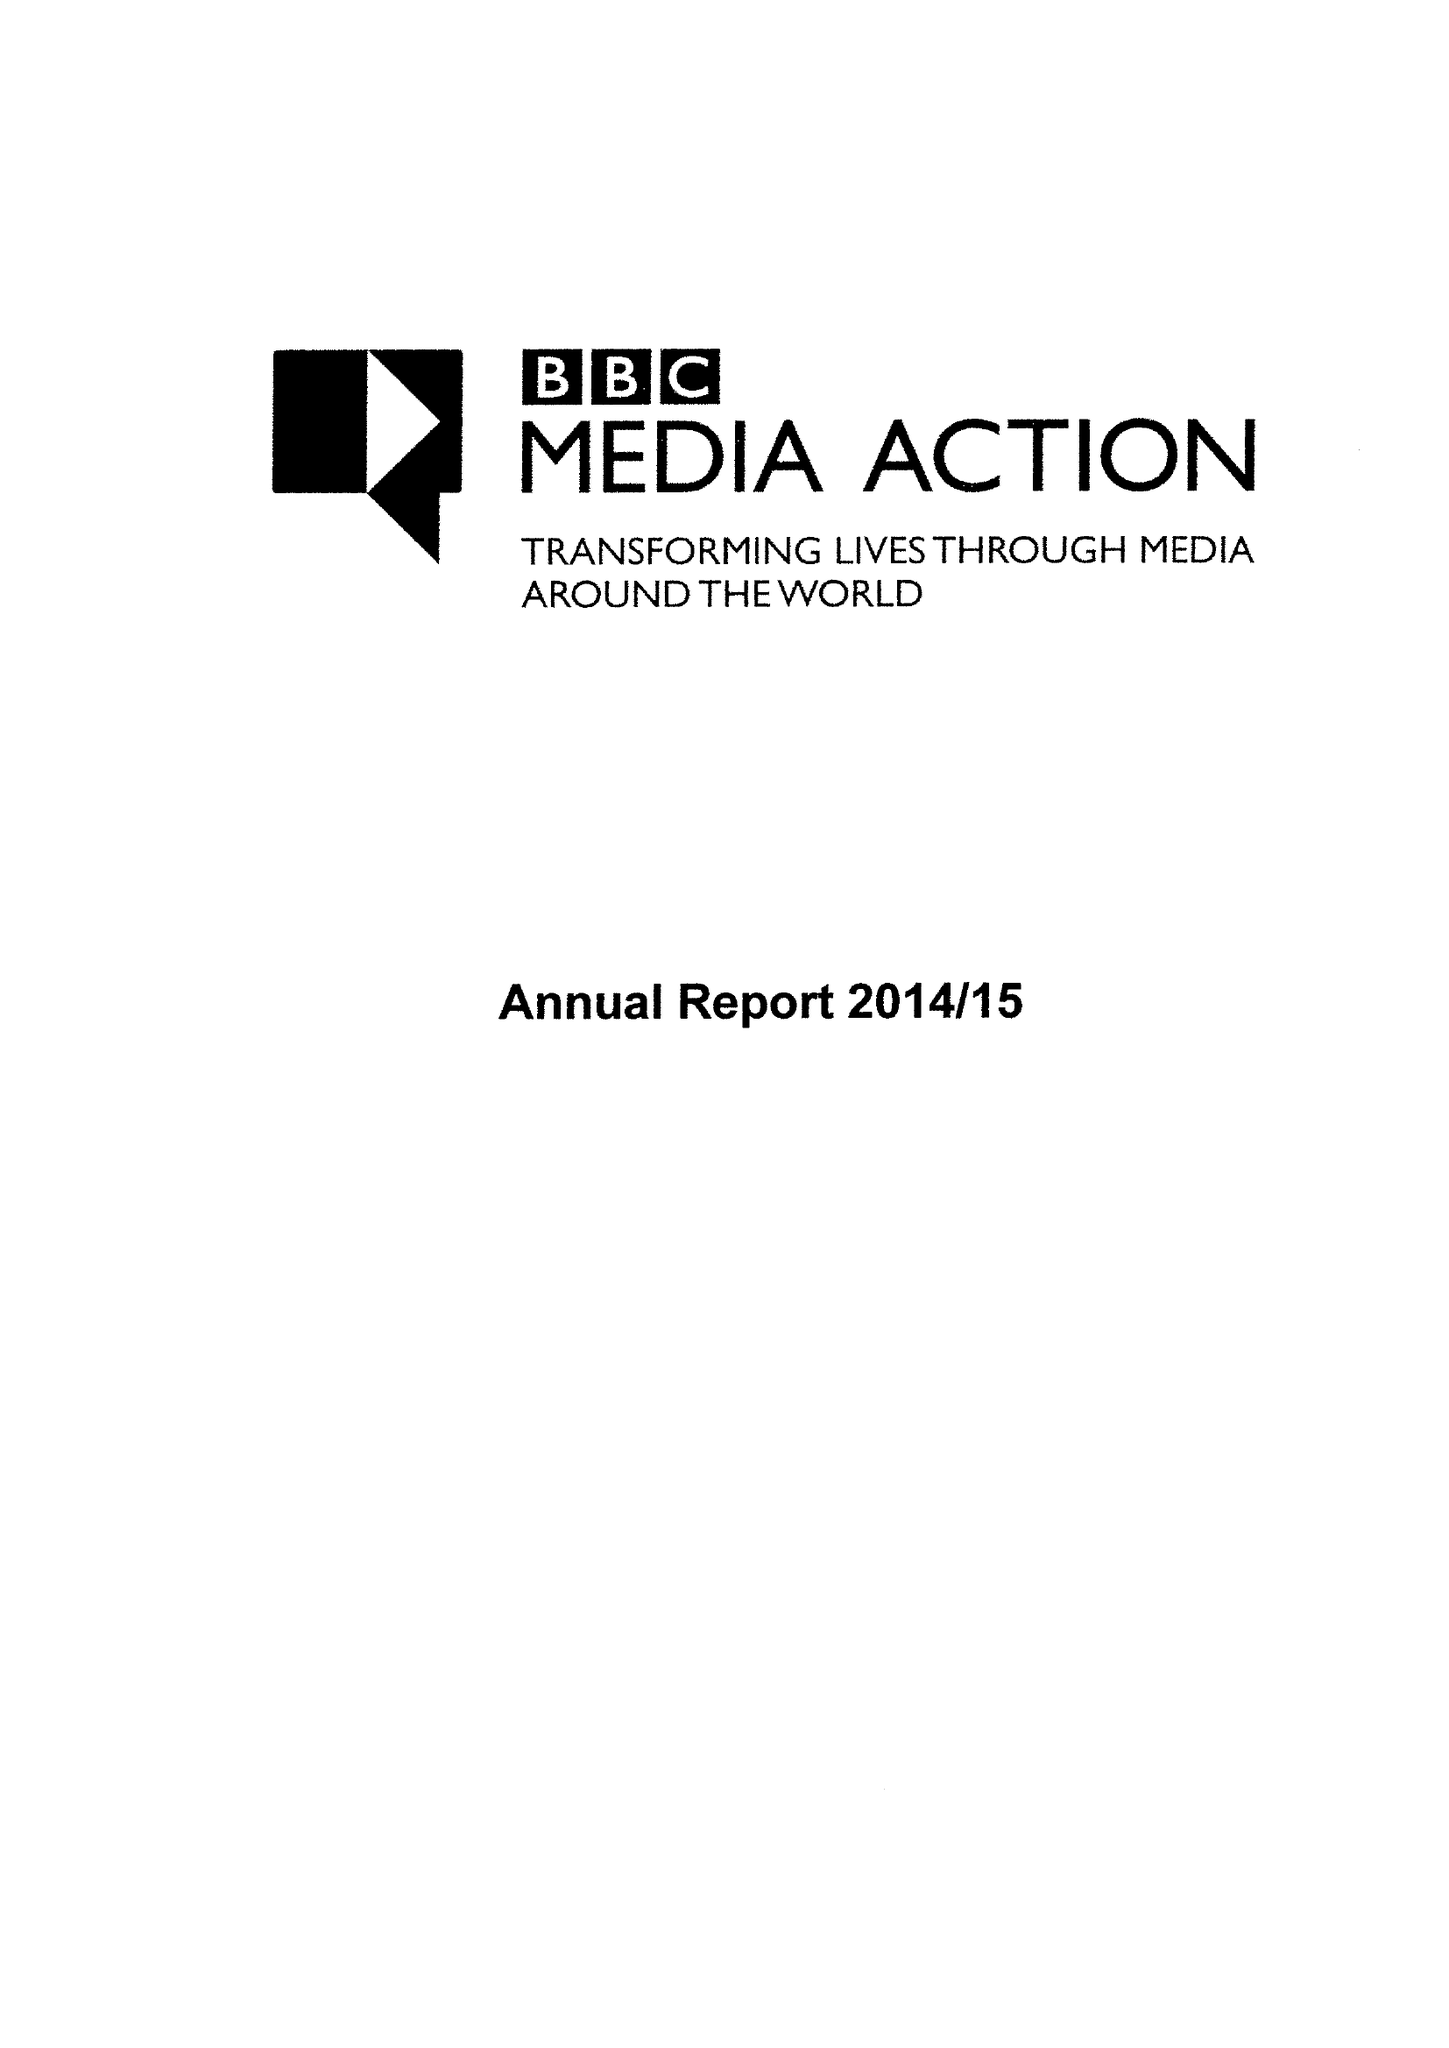What is the value for the address__postcode?
Answer the question using a single word or phrase. W1A 1AA 